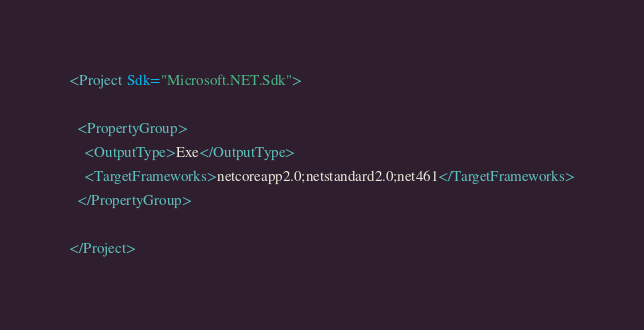<code> <loc_0><loc_0><loc_500><loc_500><_XML_><Project Sdk="Microsoft.NET.Sdk">

  <PropertyGroup>
    <OutputType>Exe</OutputType>
    <TargetFrameworks>netcoreapp2.0;netstandard2.0;net461</TargetFrameworks>
  </PropertyGroup>

</Project>
</code> 